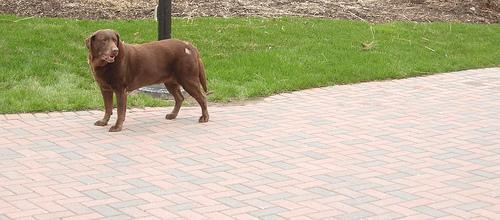How many dogs are in the photo?
Give a very brief answer. 1. How many dogs are there?
Give a very brief answer. 1. 